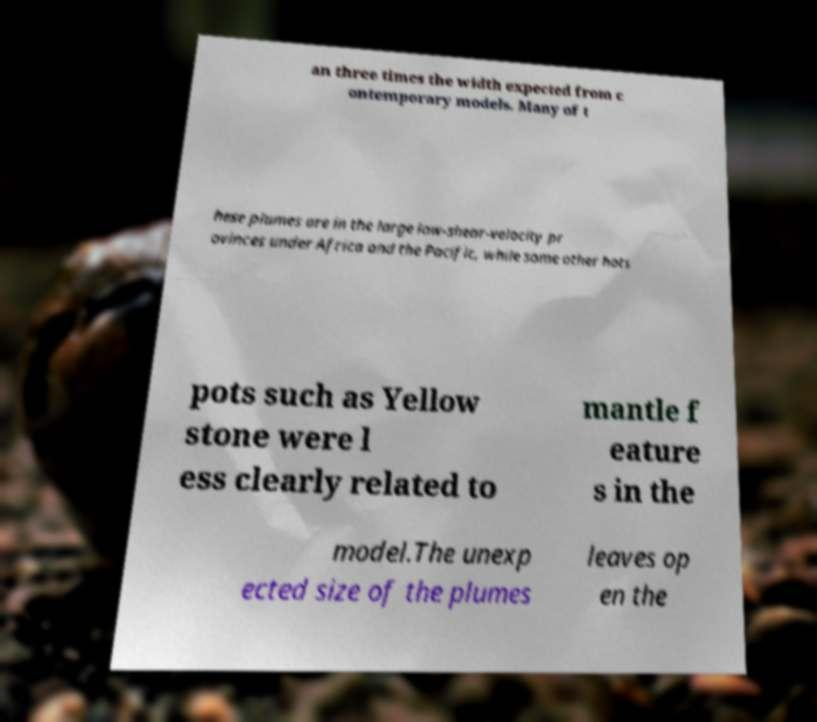Can you accurately transcribe the text from the provided image for me? an three times the width expected from c ontemporary models. Many of t hese plumes are in the large low-shear-velocity pr ovinces under Africa and the Pacific, while some other hots pots such as Yellow stone were l ess clearly related to mantle f eature s in the model.The unexp ected size of the plumes leaves op en the 